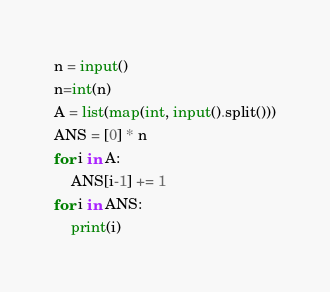Convert code to text. <code><loc_0><loc_0><loc_500><loc_500><_Python_>n = input()
n=int(n)
A = list(map(int, input().split()))
ANS = [0] * n
for i in A:
    ANS[i-1] += 1
for i in ANS:
    print(i)</code> 